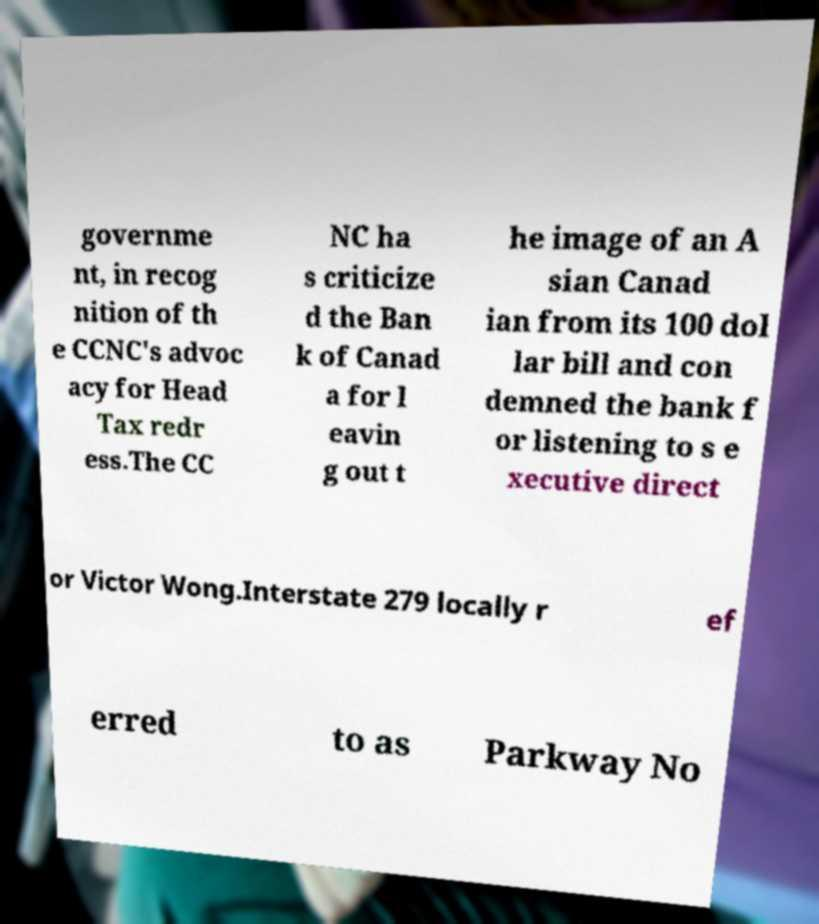Please identify and transcribe the text found in this image. governme nt, in recog nition of th e CCNC's advoc acy for Head Tax redr ess.The CC NC ha s criticize d the Ban k of Canad a for l eavin g out t he image of an A sian Canad ian from its 100 dol lar bill and con demned the bank f or listening to s e xecutive direct or Victor Wong.Interstate 279 locally r ef erred to as Parkway No 